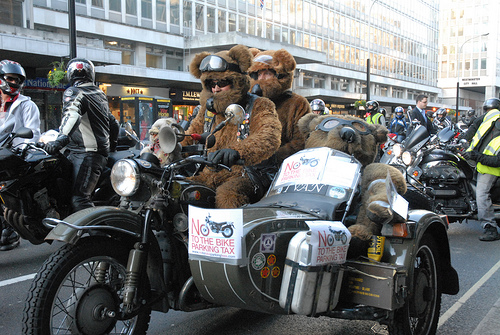Extract all visible text content from this image. NO NO PARKING No PAPKING TAX BIKE 